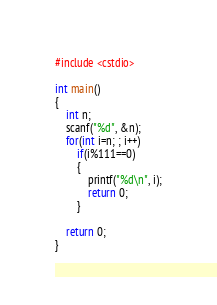<code> <loc_0><loc_0><loc_500><loc_500><_C++_>#include <cstdio>

int main()
{
	int n;
	scanf("%d", &n);
	for(int i=n; ; i++)
		if(i%111==0)
		{
			printf("%d\n", i);
			return 0;
		}
	
	return 0;
}</code> 